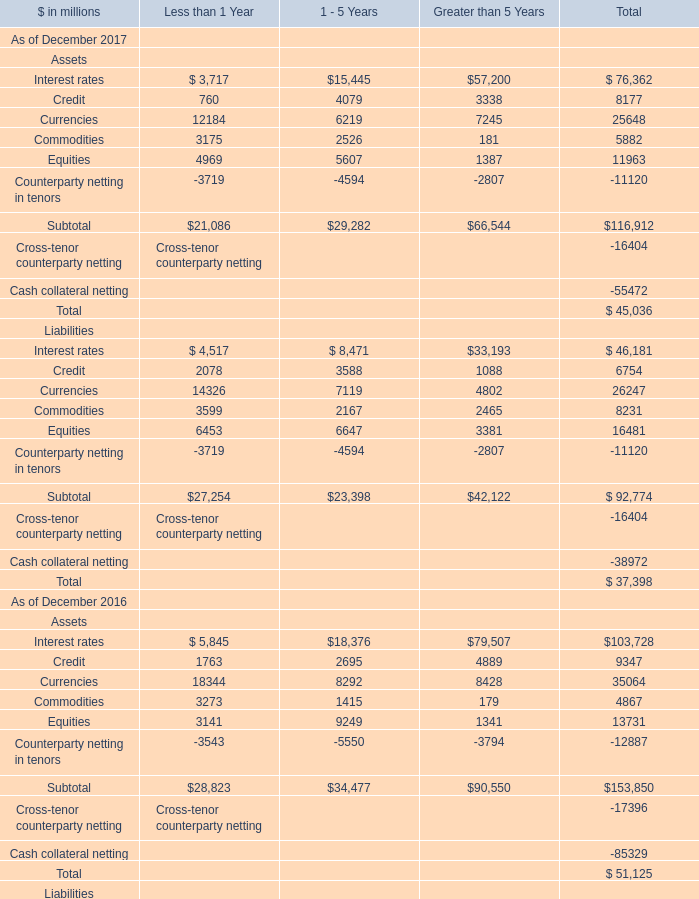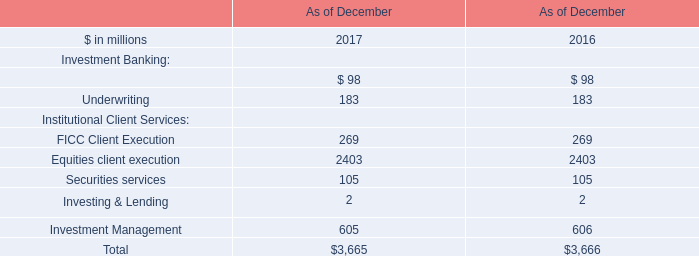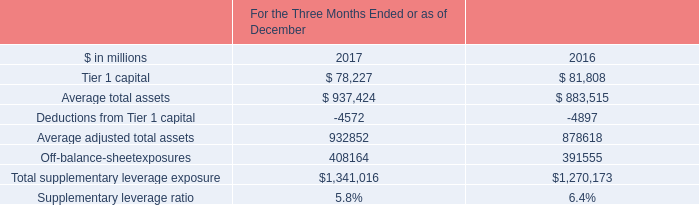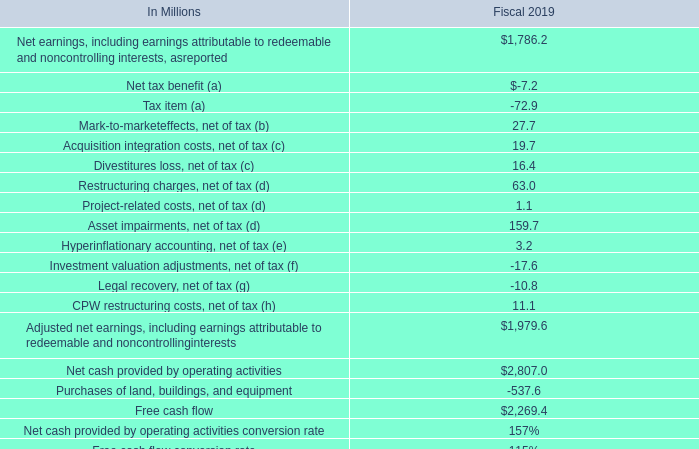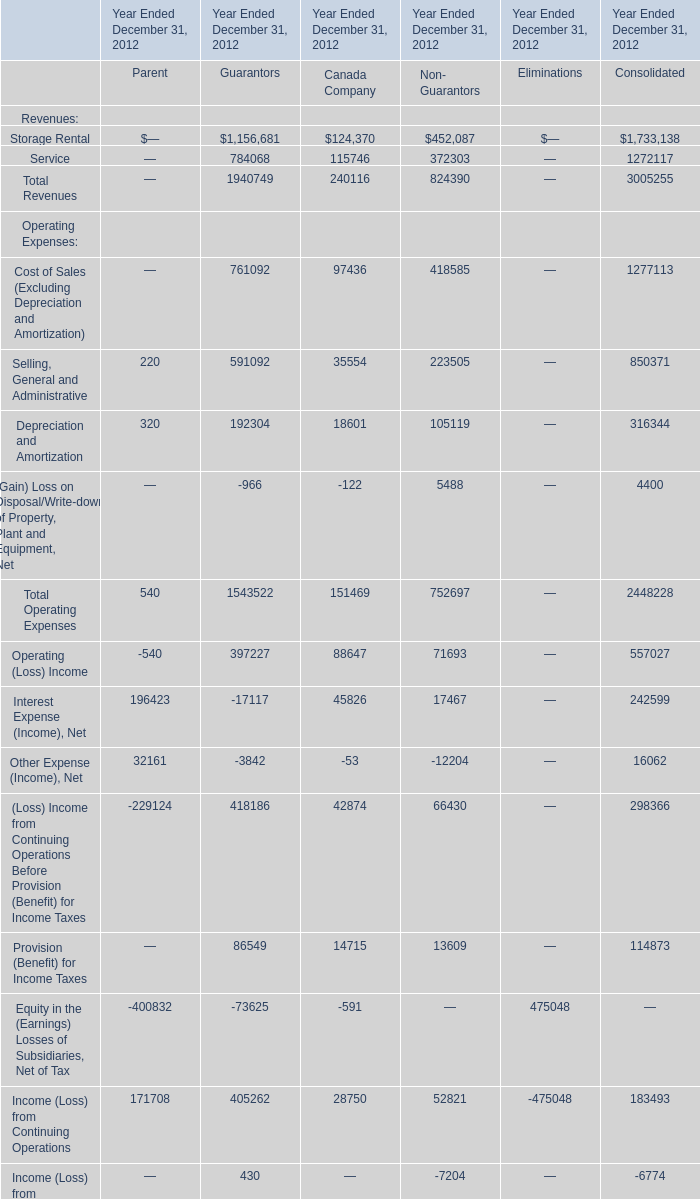What's the sum of Counterparty netting in tenors of Less than 1 Year, and Service of Year Ended December 31, 2012 Consolidated ? 
Computations: (3719.0 + 1272117.0)
Answer: 1275836.0. 